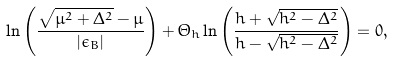Convert formula to latex. <formula><loc_0><loc_0><loc_500><loc_500>\ln \left ( \frac { \sqrt { \mu ^ { 2 } + \Delta ^ { 2 } } - \mu } { | \epsilon _ { B } | } \right ) + \Theta _ { h } \ln \left ( \frac { h + \sqrt { h ^ { 2 } - \Delta ^ { 2 } } } { h - \sqrt { h ^ { 2 } - \Delta ^ { 2 } } } \right ) = 0 ,</formula> 